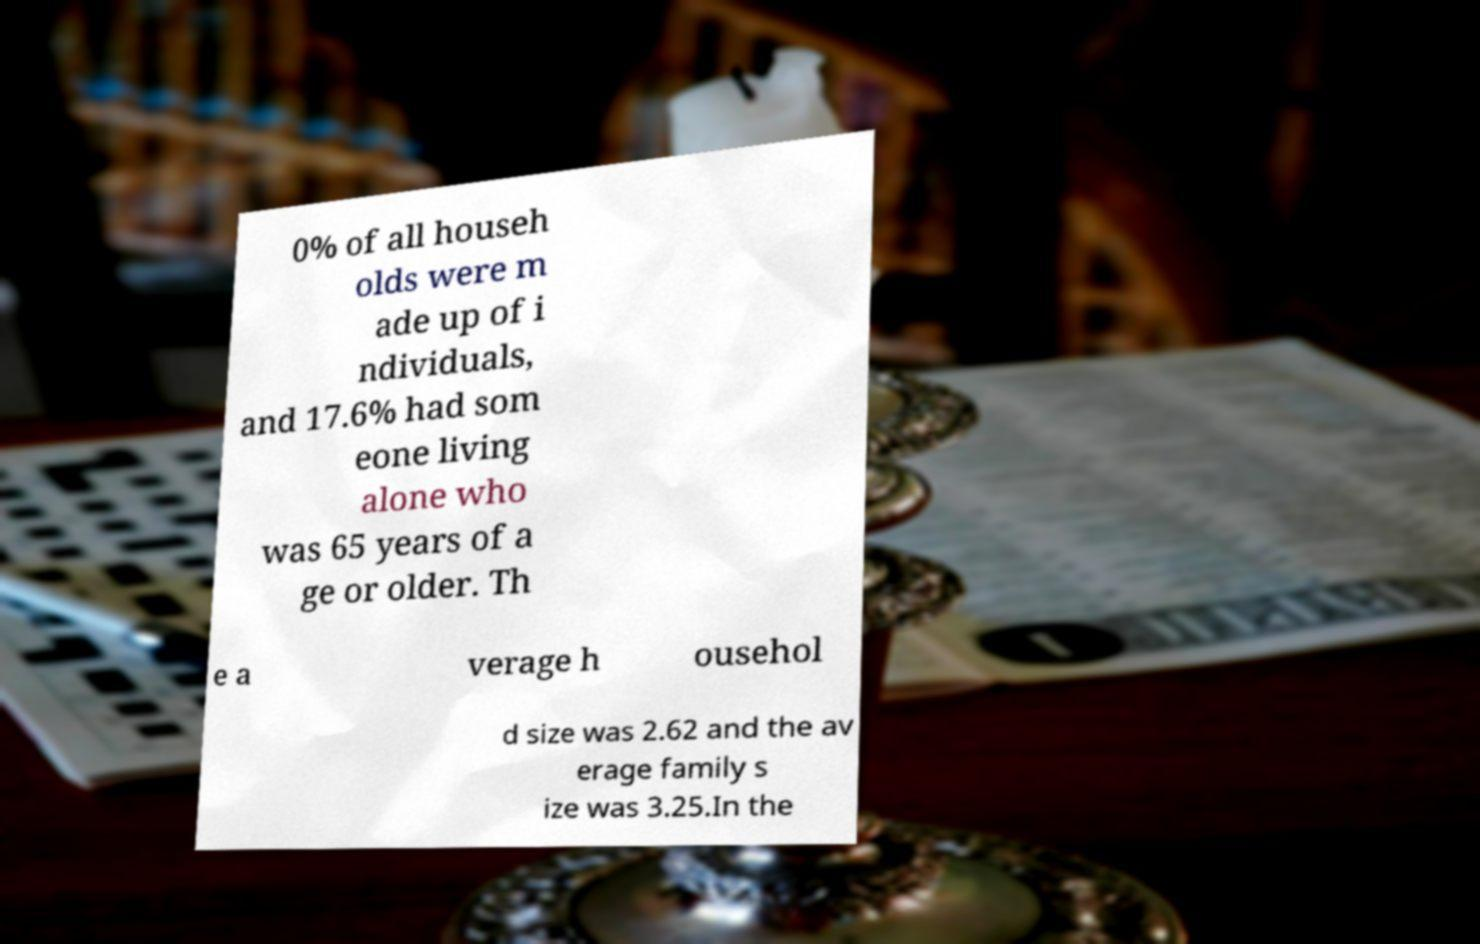For documentation purposes, I need the text within this image transcribed. Could you provide that? 0% of all househ olds were m ade up of i ndividuals, and 17.6% had som eone living alone who was 65 years of a ge or older. Th e a verage h ousehol d size was 2.62 and the av erage family s ize was 3.25.In the 